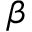Convert formula to latex. <formula><loc_0><loc_0><loc_500><loc_500>\beta</formula> 